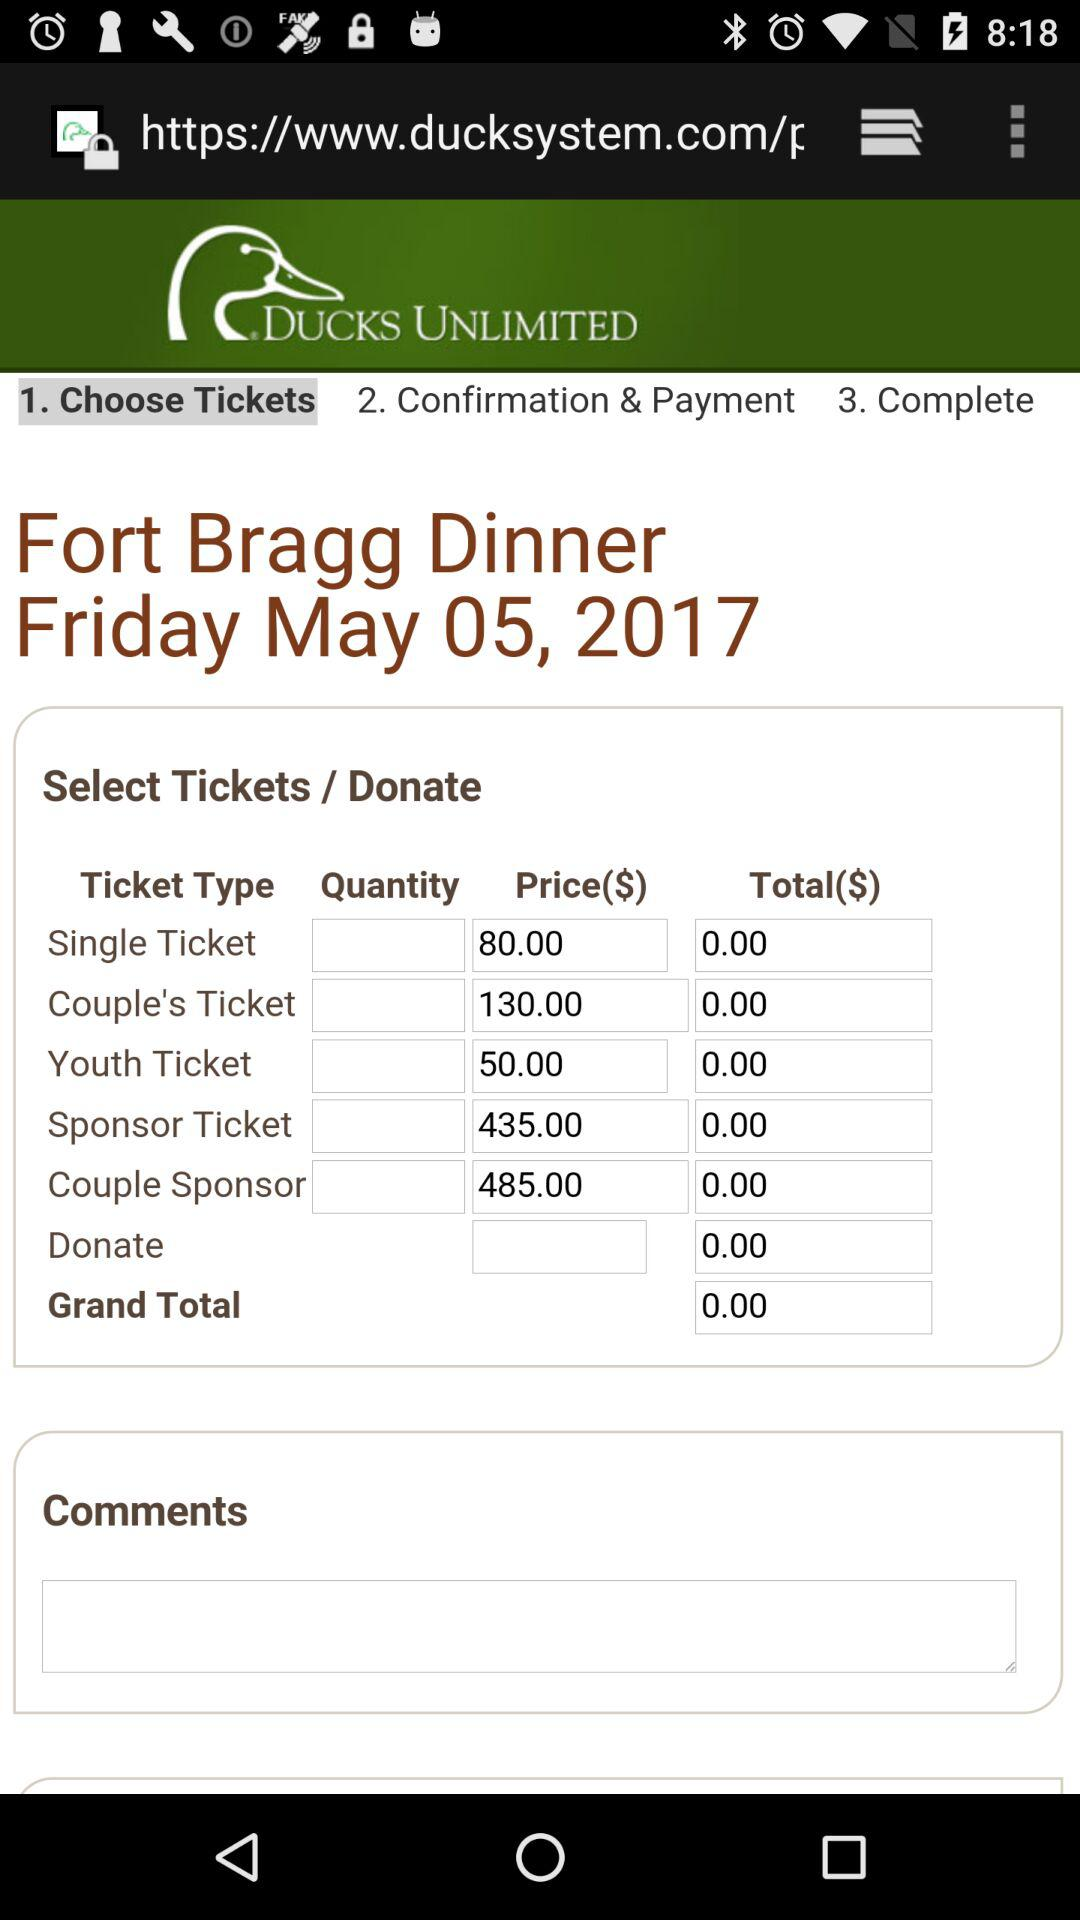What is the price of the youth ticket? The price is $50. 